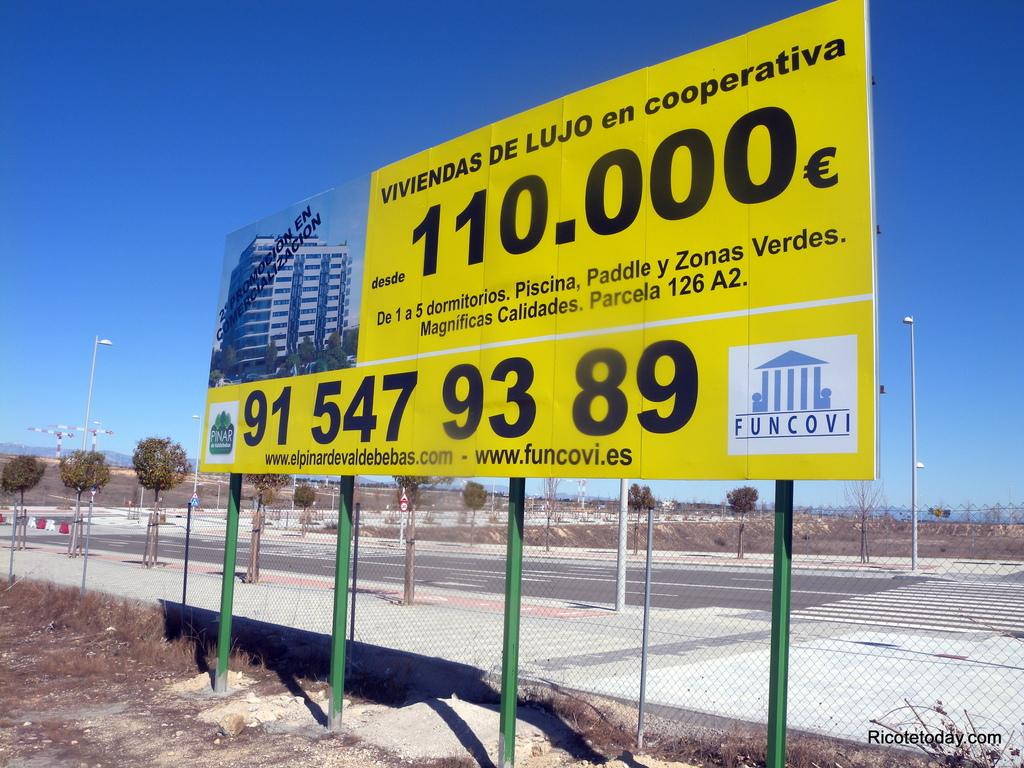Provide a one-sentence caption for the provided image. The Funcovi logo occupies the corner of a construction project billboard. 